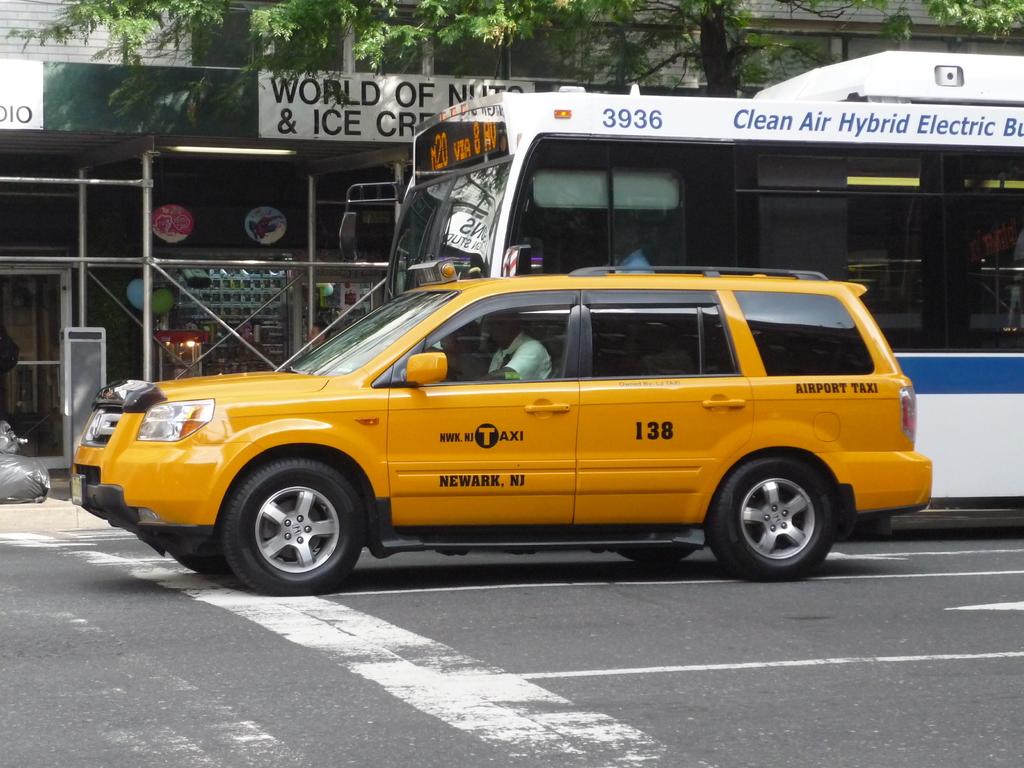What is the number of the taxi?
Give a very brief answer. 138. What number is on the bus?
Keep it short and to the point. 3936. 